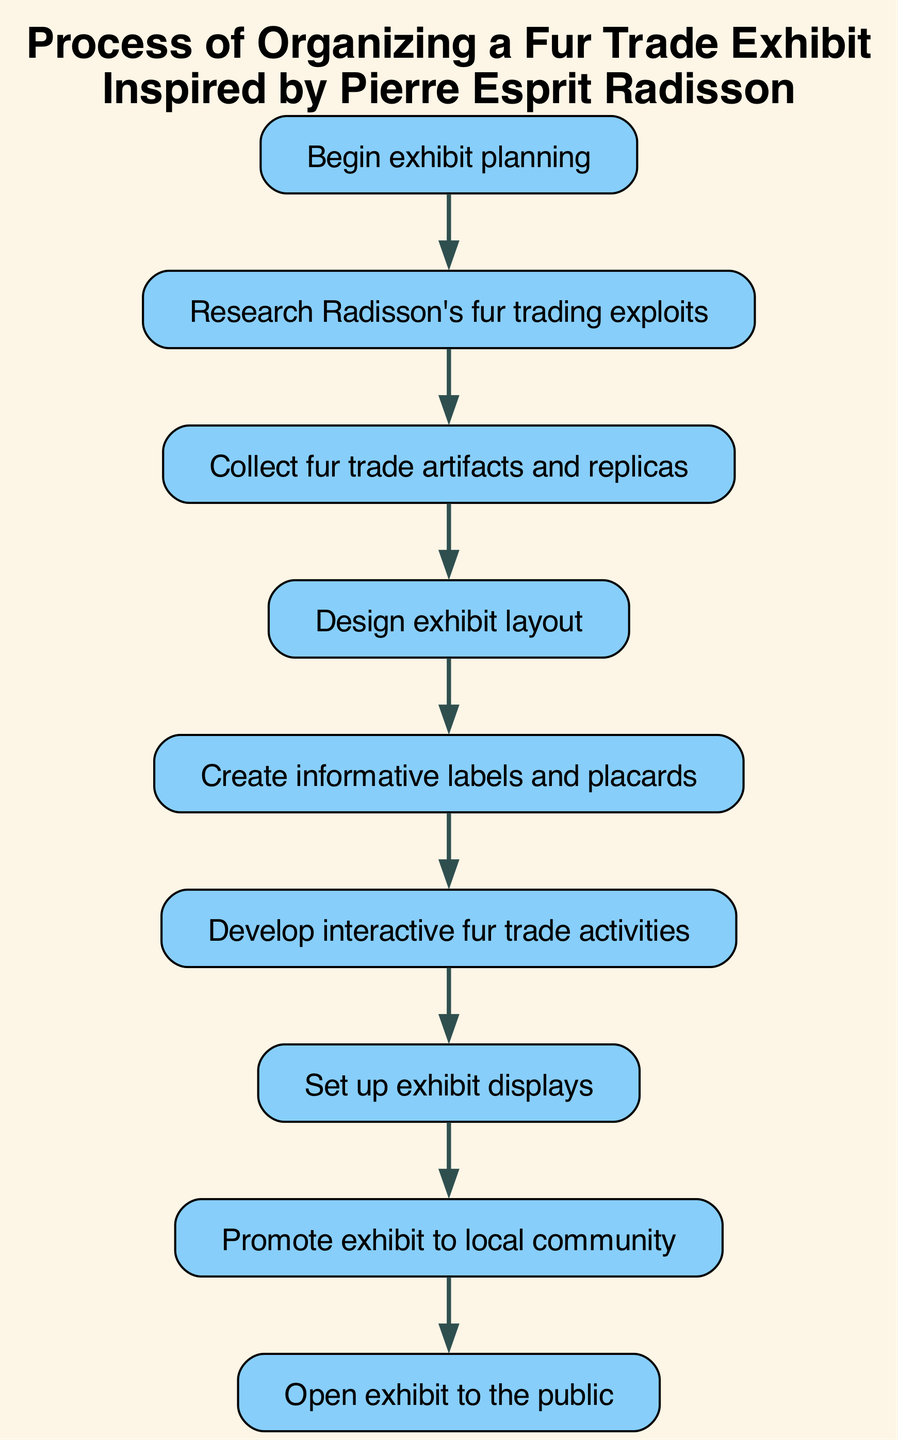What is the first step in organizing the exhibit? The first step is indicated by the starting point in the diagram, which is "Begin exhibit planning." This sets the initial action for the entire process.
Answer: Begin exhibit planning How many nodes are present in the diagram? By counting the distinct elements included in the diagram, we can identify that there are a total of 9 nodes. Each step in the process is represented as a node.
Answer: 9 What is the last step in the process? The last step is clearly stated in the diagram as "Open exhibit to the public," which indicates the conclusion of the planning and setup phase.
Answer: Open exhibit to the public What is the relationship between "labels" and "interactive"? The diagram shows a direct connection from "Create informative labels and placards" to "Develop interactive fur trade activities," indicating that the creation of labels precedes developing interactive activities.
Answer: labels lead to interactive Which step follows "Develop interactive fur trade activities"? According to the flow of the diagram, the step that follows "Develop interactive fur trade activities" is "Set up exhibit displays," which marks the transition from planning to implementation.
Answer: Set up exhibit displays What step comes before collecting artifacts? The step before "Collect fur trade artifacts and replicas" is "Research Radisson's fur trading exploits," demonstrating that research is essential to know what artifacts are relevant for collection.
Answer: Research Radisson's fur trading exploits What is the immediate step after "Design exhibit layout"? The immediate step that follows "Design exhibit layout" in the flow is "Create informative labels and placards," indicating that layout designs lead to the creation of accompanying information for the exhibit.
Answer: Create informative labels and placards How many connections are there in the diagram? By counting the lines that connect the nodes in the flowchart, we can determine that there are 8 connections showing the relationships and flow between various steps.
Answer: 8 